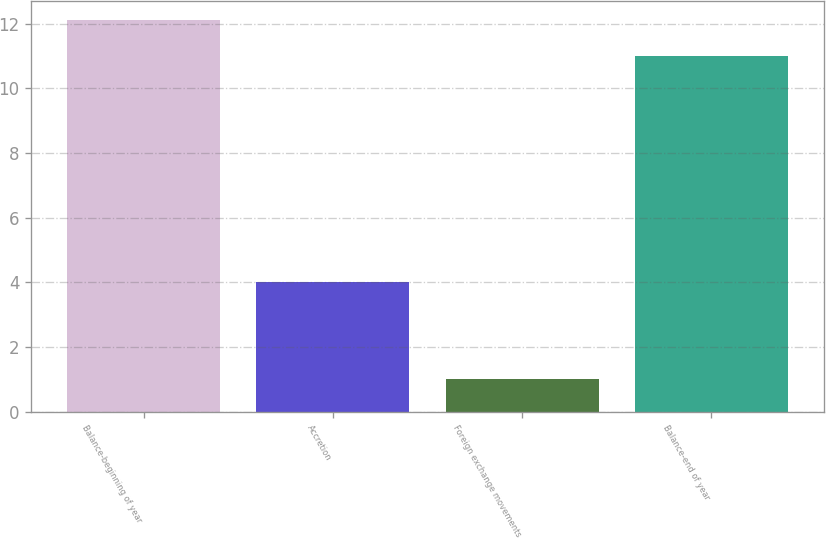<chart> <loc_0><loc_0><loc_500><loc_500><bar_chart><fcel>Balance-beginning of year<fcel>Accretion<fcel>Foreign exchange movements<fcel>Balance-end of year<nl><fcel>12.1<fcel>4<fcel>1<fcel>11<nl></chart> 